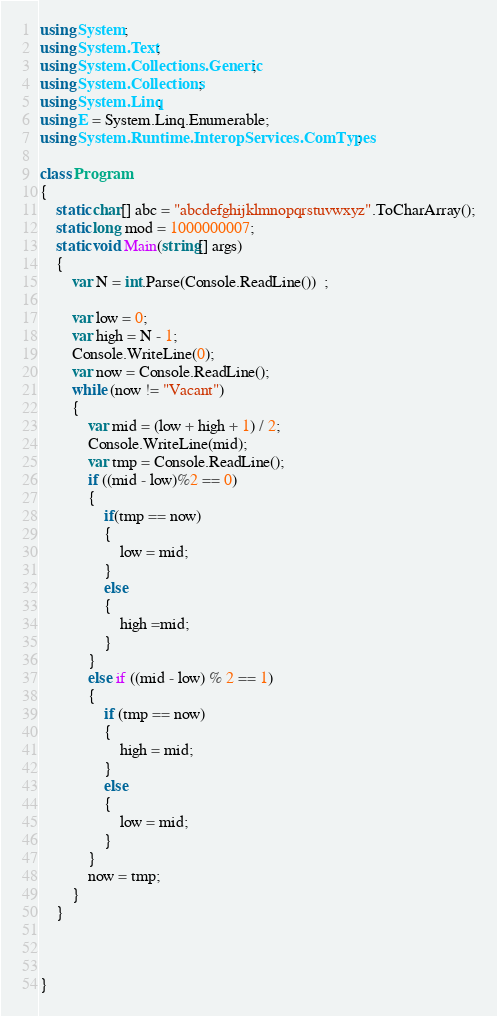<code> <loc_0><loc_0><loc_500><loc_500><_C#_>using System;
using System.Text;
using System.Collections.Generic;
using System.Collections;
using System.Linq;
using E = System.Linq.Enumerable;
using System.Runtime.InteropServices.ComTypes;

class Program
{
    static char[] abc = "abcdefghijklmnopqrstuvwxyz".ToCharArray();
    static long mod = 1000000007;
    static void Main(string[] args)
    {
        var N = int.Parse(Console.ReadLine())  ;

        var low = 0;
        var high = N - 1;
        Console.WriteLine(0);
        var now = Console.ReadLine();
        while (now != "Vacant")
        {
            var mid = (low + high + 1) / 2;
            Console.WriteLine(mid);
            var tmp = Console.ReadLine();
            if ((mid - low)%2 == 0)
            {
                if(tmp == now)
                {
                    low = mid;
                }
                else
                {
                    high =mid;
                }
            }
            else if ((mid - low) % 2 == 1)
            {
                if (tmp == now)
                {
                    high = mid;
                }
                else
                {
                    low = mid;
                }
            }
            now = tmp;
        }
    }



}
</code> 